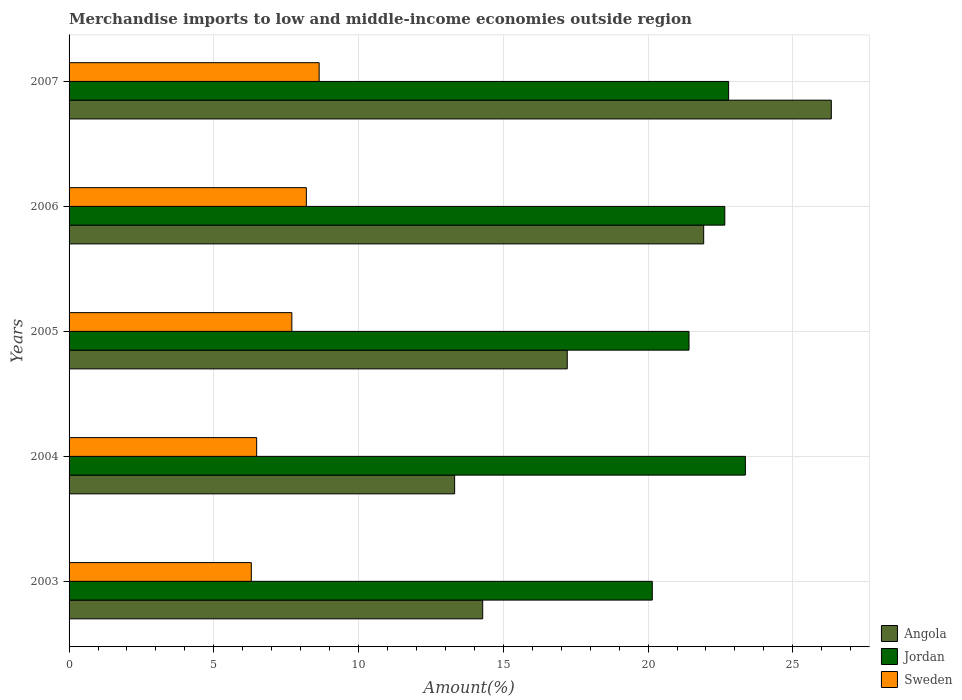How many different coloured bars are there?
Your response must be concise. 3. How many groups of bars are there?
Your response must be concise. 5. Are the number of bars per tick equal to the number of legend labels?
Offer a terse response. Yes. How many bars are there on the 3rd tick from the bottom?
Give a very brief answer. 3. What is the label of the 3rd group of bars from the top?
Your response must be concise. 2005. In how many cases, is the number of bars for a given year not equal to the number of legend labels?
Keep it short and to the point. 0. What is the percentage of amount earned from merchandise imports in Sweden in 2005?
Offer a very short reply. 7.7. Across all years, what is the maximum percentage of amount earned from merchandise imports in Sweden?
Provide a succinct answer. 8.64. Across all years, what is the minimum percentage of amount earned from merchandise imports in Jordan?
Your answer should be compact. 20.15. In which year was the percentage of amount earned from merchandise imports in Sweden maximum?
Your answer should be compact. 2007. What is the total percentage of amount earned from merchandise imports in Sweden in the graph?
Your response must be concise. 37.31. What is the difference between the percentage of amount earned from merchandise imports in Jordan in 2004 and that in 2007?
Keep it short and to the point. 0.58. What is the difference between the percentage of amount earned from merchandise imports in Sweden in 2005 and the percentage of amount earned from merchandise imports in Jordan in 2003?
Your answer should be very brief. -12.45. What is the average percentage of amount earned from merchandise imports in Jordan per year?
Provide a succinct answer. 22.07. In the year 2004, what is the difference between the percentage of amount earned from merchandise imports in Angola and percentage of amount earned from merchandise imports in Sweden?
Offer a terse response. 6.84. In how many years, is the percentage of amount earned from merchandise imports in Jordan greater than 26 %?
Your response must be concise. 0. What is the ratio of the percentage of amount earned from merchandise imports in Angola in 2004 to that in 2006?
Your answer should be very brief. 0.61. Is the difference between the percentage of amount earned from merchandise imports in Angola in 2005 and 2007 greater than the difference between the percentage of amount earned from merchandise imports in Sweden in 2005 and 2007?
Offer a very short reply. No. What is the difference between the highest and the second highest percentage of amount earned from merchandise imports in Jordan?
Keep it short and to the point. 0.58. What is the difference between the highest and the lowest percentage of amount earned from merchandise imports in Jordan?
Provide a short and direct response. 3.22. Is the sum of the percentage of amount earned from merchandise imports in Jordan in 2004 and 2007 greater than the maximum percentage of amount earned from merchandise imports in Sweden across all years?
Provide a short and direct response. Yes. What does the 1st bar from the top in 2007 represents?
Your response must be concise. Sweden. Is it the case that in every year, the sum of the percentage of amount earned from merchandise imports in Jordan and percentage of amount earned from merchandise imports in Sweden is greater than the percentage of amount earned from merchandise imports in Angola?
Give a very brief answer. Yes. How many bars are there?
Offer a very short reply. 15. What is the difference between two consecutive major ticks on the X-axis?
Give a very brief answer. 5. Where does the legend appear in the graph?
Keep it short and to the point. Bottom right. How are the legend labels stacked?
Provide a short and direct response. Vertical. What is the title of the graph?
Provide a succinct answer. Merchandise imports to low and middle-income economies outside region. What is the label or title of the X-axis?
Keep it short and to the point. Amount(%). What is the Amount(%) in Angola in 2003?
Keep it short and to the point. 14.29. What is the Amount(%) of Jordan in 2003?
Keep it short and to the point. 20.15. What is the Amount(%) in Sweden in 2003?
Your answer should be very brief. 6.3. What is the Amount(%) of Angola in 2004?
Keep it short and to the point. 13.32. What is the Amount(%) in Jordan in 2004?
Your answer should be very brief. 23.36. What is the Amount(%) in Sweden in 2004?
Provide a succinct answer. 6.48. What is the Amount(%) of Angola in 2005?
Offer a very short reply. 17.21. What is the Amount(%) of Jordan in 2005?
Offer a terse response. 21.42. What is the Amount(%) in Sweden in 2005?
Offer a terse response. 7.7. What is the Amount(%) in Angola in 2006?
Give a very brief answer. 21.92. What is the Amount(%) in Jordan in 2006?
Your answer should be compact. 22.65. What is the Amount(%) in Sweden in 2006?
Provide a succinct answer. 8.2. What is the Amount(%) of Angola in 2007?
Give a very brief answer. 26.33. What is the Amount(%) of Jordan in 2007?
Give a very brief answer. 22.78. What is the Amount(%) in Sweden in 2007?
Give a very brief answer. 8.64. Across all years, what is the maximum Amount(%) of Angola?
Provide a short and direct response. 26.33. Across all years, what is the maximum Amount(%) of Jordan?
Provide a succinct answer. 23.36. Across all years, what is the maximum Amount(%) in Sweden?
Keep it short and to the point. 8.64. Across all years, what is the minimum Amount(%) of Angola?
Make the answer very short. 13.32. Across all years, what is the minimum Amount(%) of Jordan?
Provide a succinct answer. 20.15. Across all years, what is the minimum Amount(%) in Sweden?
Your answer should be compact. 6.3. What is the total Amount(%) in Angola in the graph?
Provide a succinct answer. 93.07. What is the total Amount(%) of Jordan in the graph?
Offer a terse response. 110.36. What is the total Amount(%) in Sweden in the graph?
Your response must be concise. 37.31. What is the difference between the Amount(%) of Angola in 2003 and that in 2004?
Your response must be concise. 0.97. What is the difference between the Amount(%) in Jordan in 2003 and that in 2004?
Offer a very short reply. -3.22. What is the difference between the Amount(%) in Sweden in 2003 and that in 2004?
Offer a terse response. -0.18. What is the difference between the Amount(%) in Angola in 2003 and that in 2005?
Give a very brief answer. -2.92. What is the difference between the Amount(%) of Jordan in 2003 and that in 2005?
Your answer should be compact. -1.27. What is the difference between the Amount(%) of Sweden in 2003 and that in 2005?
Your answer should be very brief. -1.4. What is the difference between the Amount(%) of Angola in 2003 and that in 2006?
Offer a terse response. -7.63. What is the difference between the Amount(%) in Jordan in 2003 and that in 2006?
Offer a very short reply. -2.51. What is the difference between the Amount(%) of Sweden in 2003 and that in 2006?
Your answer should be very brief. -1.9. What is the difference between the Amount(%) of Angola in 2003 and that in 2007?
Your answer should be compact. -12.04. What is the difference between the Amount(%) in Jordan in 2003 and that in 2007?
Offer a very short reply. -2.64. What is the difference between the Amount(%) in Sweden in 2003 and that in 2007?
Offer a terse response. -2.34. What is the difference between the Amount(%) in Angola in 2004 and that in 2005?
Give a very brief answer. -3.89. What is the difference between the Amount(%) in Jordan in 2004 and that in 2005?
Offer a very short reply. 1.95. What is the difference between the Amount(%) of Sweden in 2004 and that in 2005?
Keep it short and to the point. -1.22. What is the difference between the Amount(%) of Angola in 2004 and that in 2006?
Offer a terse response. -8.6. What is the difference between the Amount(%) in Jordan in 2004 and that in 2006?
Your answer should be compact. 0.71. What is the difference between the Amount(%) in Sweden in 2004 and that in 2006?
Keep it short and to the point. -1.72. What is the difference between the Amount(%) in Angola in 2004 and that in 2007?
Your answer should be compact. -13.01. What is the difference between the Amount(%) in Jordan in 2004 and that in 2007?
Give a very brief answer. 0.58. What is the difference between the Amount(%) of Sweden in 2004 and that in 2007?
Make the answer very short. -2.16. What is the difference between the Amount(%) of Angola in 2005 and that in 2006?
Ensure brevity in your answer.  -4.71. What is the difference between the Amount(%) of Jordan in 2005 and that in 2006?
Ensure brevity in your answer.  -1.24. What is the difference between the Amount(%) in Sweden in 2005 and that in 2006?
Provide a short and direct response. -0.5. What is the difference between the Amount(%) in Angola in 2005 and that in 2007?
Your answer should be compact. -9.12. What is the difference between the Amount(%) of Jordan in 2005 and that in 2007?
Offer a terse response. -1.37. What is the difference between the Amount(%) in Sweden in 2005 and that in 2007?
Your response must be concise. -0.94. What is the difference between the Amount(%) in Angola in 2006 and that in 2007?
Your answer should be very brief. -4.41. What is the difference between the Amount(%) of Jordan in 2006 and that in 2007?
Your answer should be compact. -0.13. What is the difference between the Amount(%) in Sweden in 2006 and that in 2007?
Your answer should be compact. -0.44. What is the difference between the Amount(%) of Angola in 2003 and the Amount(%) of Jordan in 2004?
Ensure brevity in your answer.  -9.07. What is the difference between the Amount(%) of Angola in 2003 and the Amount(%) of Sweden in 2004?
Ensure brevity in your answer.  7.81. What is the difference between the Amount(%) in Jordan in 2003 and the Amount(%) in Sweden in 2004?
Ensure brevity in your answer.  13.67. What is the difference between the Amount(%) of Angola in 2003 and the Amount(%) of Jordan in 2005?
Offer a terse response. -7.13. What is the difference between the Amount(%) of Angola in 2003 and the Amount(%) of Sweden in 2005?
Your answer should be very brief. 6.59. What is the difference between the Amount(%) of Jordan in 2003 and the Amount(%) of Sweden in 2005?
Give a very brief answer. 12.45. What is the difference between the Amount(%) in Angola in 2003 and the Amount(%) in Jordan in 2006?
Your response must be concise. -8.36. What is the difference between the Amount(%) in Angola in 2003 and the Amount(%) in Sweden in 2006?
Your answer should be very brief. 6.09. What is the difference between the Amount(%) of Jordan in 2003 and the Amount(%) of Sweden in 2006?
Provide a short and direct response. 11.95. What is the difference between the Amount(%) in Angola in 2003 and the Amount(%) in Jordan in 2007?
Your answer should be very brief. -8.49. What is the difference between the Amount(%) in Angola in 2003 and the Amount(%) in Sweden in 2007?
Your answer should be very brief. 5.65. What is the difference between the Amount(%) of Jordan in 2003 and the Amount(%) of Sweden in 2007?
Offer a very short reply. 11.51. What is the difference between the Amount(%) in Angola in 2004 and the Amount(%) in Jordan in 2005?
Your answer should be compact. -8.1. What is the difference between the Amount(%) of Angola in 2004 and the Amount(%) of Sweden in 2005?
Offer a terse response. 5.62. What is the difference between the Amount(%) of Jordan in 2004 and the Amount(%) of Sweden in 2005?
Your answer should be very brief. 15.67. What is the difference between the Amount(%) in Angola in 2004 and the Amount(%) in Jordan in 2006?
Your answer should be very brief. -9.33. What is the difference between the Amount(%) of Angola in 2004 and the Amount(%) of Sweden in 2006?
Give a very brief answer. 5.12. What is the difference between the Amount(%) of Jordan in 2004 and the Amount(%) of Sweden in 2006?
Offer a terse response. 15.16. What is the difference between the Amount(%) of Angola in 2004 and the Amount(%) of Jordan in 2007?
Your answer should be compact. -9.46. What is the difference between the Amount(%) of Angola in 2004 and the Amount(%) of Sweden in 2007?
Offer a very short reply. 4.68. What is the difference between the Amount(%) of Jordan in 2004 and the Amount(%) of Sweden in 2007?
Your answer should be compact. 14.72. What is the difference between the Amount(%) of Angola in 2005 and the Amount(%) of Jordan in 2006?
Provide a short and direct response. -5.44. What is the difference between the Amount(%) in Angola in 2005 and the Amount(%) in Sweden in 2006?
Make the answer very short. 9.01. What is the difference between the Amount(%) of Jordan in 2005 and the Amount(%) of Sweden in 2006?
Ensure brevity in your answer.  13.22. What is the difference between the Amount(%) in Angola in 2005 and the Amount(%) in Jordan in 2007?
Ensure brevity in your answer.  -5.57. What is the difference between the Amount(%) of Angola in 2005 and the Amount(%) of Sweden in 2007?
Provide a succinct answer. 8.57. What is the difference between the Amount(%) of Jordan in 2005 and the Amount(%) of Sweden in 2007?
Your answer should be very brief. 12.78. What is the difference between the Amount(%) of Angola in 2006 and the Amount(%) of Jordan in 2007?
Offer a terse response. -0.86. What is the difference between the Amount(%) of Angola in 2006 and the Amount(%) of Sweden in 2007?
Offer a very short reply. 13.28. What is the difference between the Amount(%) of Jordan in 2006 and the Amount(%) of Sweden in 2007?
Give a very brief answer. 14.01. What is the average Amount(%) in Angola per year?
Make the answer very short. 18.61. What is the average Amount(%) of Jordan per year?
Make the answer very short. 22.07. What is the average Amount(%) in Sweden per year?
Offer a very short reply. 7.46. In the year 2003, what is the difference between the Amount(%) of Angola and Amount(%) of Jordan?
Make the answer very short. -5.86. In the year 2003, what is the difference between the Amount(%) in Angola and Amount(%) in Sweden?
Provide a short and direct response. 7.99. In the year 2003, what is the difference between the Amount(%) of Jordan and Amount(%) of Sweden?
Keep it short and to the point. 13.85. In the year 2004, what is the difference between the Amount(%) of Angola and Amount(%) of Jordan?
Offer a very short reply. -10.04. In the year 2004, what is the difference between the Amount(%) of Angola and Amount(%) of Sweden?
Offer a terse response. 6.84. In the year 2004, what is the difference between the Amount(%) in Jordan and Amount(%) in Sweden?
Your answer should be very brief. 16.88. In the year 2005, what is the difference between the Amount(%) of Angola and Amount(%) of Jordan?
Provide a succinct answer. -4.21. In the year 2005, what is the difference between the Amount(%) in Angola and Amount(%) in Sweden?
Provide a short and direct response. 9.51. In the year 2005, what is the difference between the Amount(%) of Jordan and Amount(%) of Sweden?
Make the answer very short. 13.72. In the year 2006, what is the difference between the Amount(%) of Angola and Amount(%) of Jordan?
Offer a terse response. -0.73. In the year 2006, what is the difference between the Amount(%) of Angola and Amount(%) of Sweden?
Give a very brief answer. 13.72. In the year 2006, what is the difference between the Amount(%) in Jordan and Amount(%) in Sweden?
Make the answer very short. 14.45. In the year 2007, what is the difference between the Amount(%) of Angola and Amount(%) of Jordan?
Keep it short and to the point. 3.55. In the year 2007, what is the difference between the Amount(%) of Angola and Amount(%) of Sweden?
Provide a short and direct response. 17.69. In the year 2007, what is the difference between the Amount(%) of Jordan and Amount(%) of Sweden?
Provide a short and direct response. 14.14. What is the ratio of the Amount(%) of Angola in 2003 to that in 2004?
Provide a succinct answer. 1.07. What is the ratio of the Amount(%) of Jordan in 2003 to that in 2004?
Offer a very short reply. 0.86. What is the ratio of the Amount(%) of Sweden in 2003 to that in 2004?
Ensure brevity in your answer.  0.97. What is the ratio of the Amount(%) of Angola in 2003 to that in 2005?
Your answer should be very brief. 0.83. What is the ratio of the Amount(%) of Jordan in 2003 to that in 2005?
Offer a terse response. 0.94. What is the ratio of the Amount(%) in Sweden in 2003 to that in 2005?
Make the answer very short. 0.82. What is the ratio of the Amount(%) of Angola in 2003 to that in 2006?
Your answer should be compact. 0.65. What is the ratio of the Amount(%) in Jordan in 2003 to that in 2006?
Keep it short and to the point. 0.89. What is the ratio of the Amount(%) of Sweden in 2003 to that in 2006?
Your answer should be compact. 0.77. What is the ratio of the Amount(%) of Angola in 2003 to that in 2007?
Give a very brief answer. 0.54. What is the ratio of the Amount(%) in Jordan in 2003 to that in 2007?
Keep it short and to the point. 0.88. What is the ratio of the Amount(%) of Sweden in 2003 to that in 2007?
Your answer should be very brief. 0.73. What is the ratio of the Amount(%) in Angola in 2004 to that in 2005?
Your response must be concise. 0.77. What is the ratio of the Amount(%) of Sweden in 2004 to that in 2005?
Give a very brief answer. 0.84. What is the ratio of the Amount(%) in Angola in 2004 to that in 2006?
Your answer should be very brief. 0.61. What is the ratio of the Amount(%) in Jordan in 2004 to that in 2006?
Offer a terse response. 1.03. What is the ratio of the Amount(%) of Sweden in 2004 to that in 2006?
Provide a succinct answer. 0.79. What is the ratio of the Amount(%) of Angola in 2004 to that in 2007?
Keep it short and to the point. 0.51. What is the ratio of the Amount(%) in Jordan in 2004 to that in 2007?
Your response must be concise. 1.03. What is the ratio of the Amount(%) of Sweden in 2004 to that in 2007?
Your response must be concise. 0.75. What is the ratio of the Amount(%) in Angola in 2005 to that in 2006?
Keep it short and to the point. 0.79. What is the ratio of the Amount(%) of Jordan in 2005 to that in 2006?
Give a very brief answer. 0.95. What is the ratio of the Amount(%) of Sweden in 2005 to that in 2006?
Offer a very short reply. 0.94. What is the ratio of the Amount(%) of Angola in 2005 to that in 2007?
Provide a succinct answer. 0.65. What is the ratio of the Amount(%) in Jordan in 2005 to that in 2007?
Offer a terse response. 0.94. What is the ratio of the Amount(%) in Sweden in 2005 to that in 2007?
Give a very brief answer. 0.89. What is the ratio of the Amount(%) of Angola in 2006 to that in 2007?
Provide a succinct answer. 0.83. What is the ratio of the Amount(%) of Sweden in 2006 to that in 2007?
Provide a succinct answer. 0.95. What is the difference between the highest and the second highest Amount(%) in Angola?
Make the answer very short. 4.41. What is the difference between the highest and the second highest Amount(%) of Jordan?
Ensure brevity in your answer.  0.58. What is the difference between the highest and the second highest Amount(%) of Sweden?
Ensure brevity in your answer.  0.44. What is the difference between the highest and the lowest Amount(%) of Angola?
Your answer should be compact. 13.01. What is the difference between the highest and the lowest Amount(%) in Jordan?
Your answer should be very brief. 3.22. What is the difference between the highest and the lowest Amount(%) of Sweden?
Make the answer very short. 2.34. 